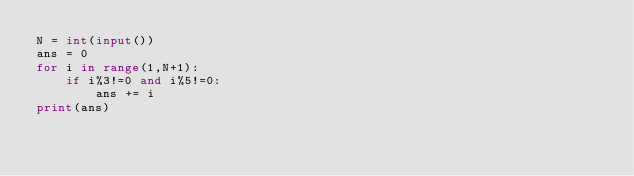<code> <loc_0><loc_0><loc_500><loc_500><_Python_>N = int(input())
ans = 0
for i in range(1,N+1):
    if i%3!=0 and i%5!=0:
        ans += i
print(ans)
</code> 